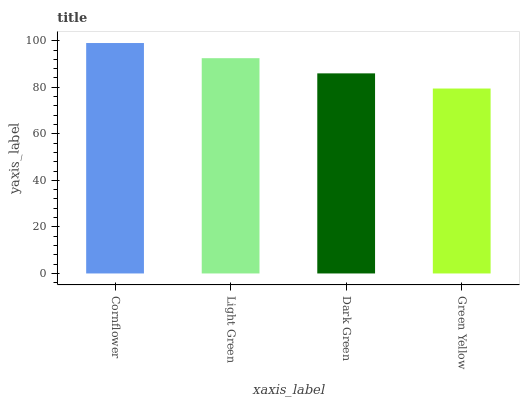Is Green Yellow the minimum?
Answer yes or no. Yes. Is Cornflower the maximum?
Answer yes or no. Yes. Is Light Green the minimum?
Answer yes or no. No. Is Light Green the maximum?
Answer yes or no. No. Is Cornflower greater than Light Green?
Answer yes or no. Yes. Is Light Green less than Cornflower?
Answer yes or no. Yes. Is Light Green greater than Cornflower?
Answer yes or no. No. Is Cornflower less than Light Green?
Answer yes or no. No. Is Light Green the high median?
Answer yes or no. Yes. Is Dark Green the low median?
Answer yes or no. Yes. Is Green Yellow the high median?
Answer yes or no. No. Is Cornflower the low median?
Answer yes or no. No. 